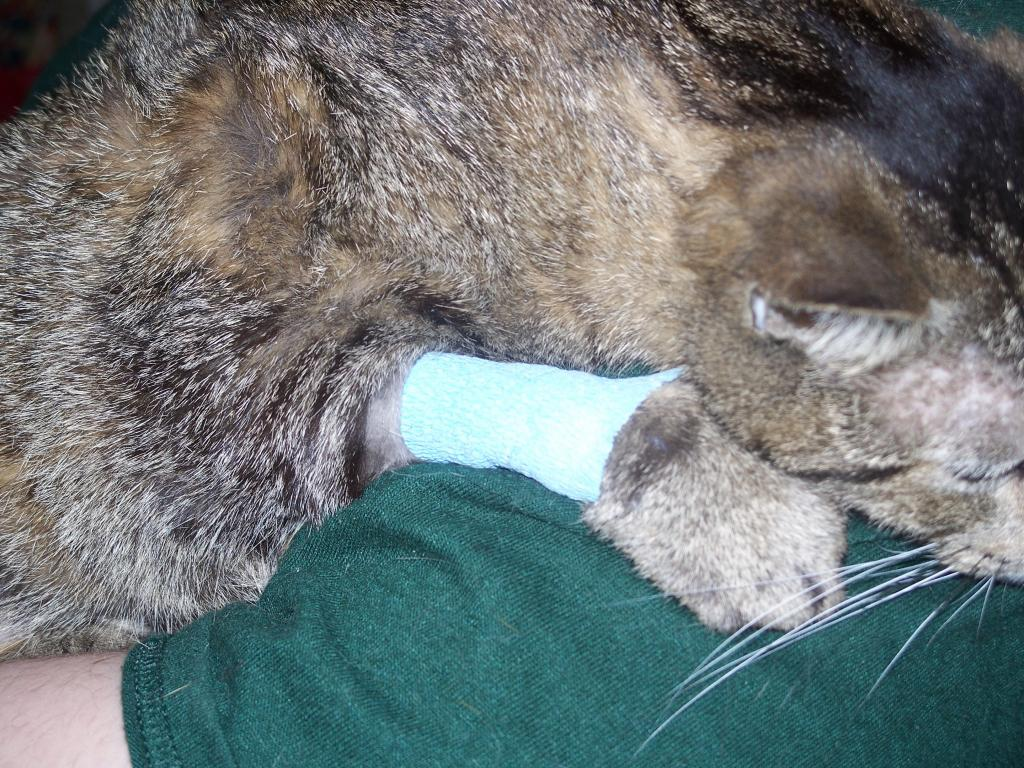What type of animal is in the image? There is a dog in the image. Does the dog have any distinguishing features? Yes, the dog has a band. What is the dog doing in the image? The dog is laying on a human. What type of material is visible in the image? Cloth is visible in the image. What else can be seen in the image besides the dog and cloth? A human body is present in the image. What type of oil can be seen dripping from the dog's band in the image? There is no oil present in the image, and the dog's band is not shown dripping anything. 